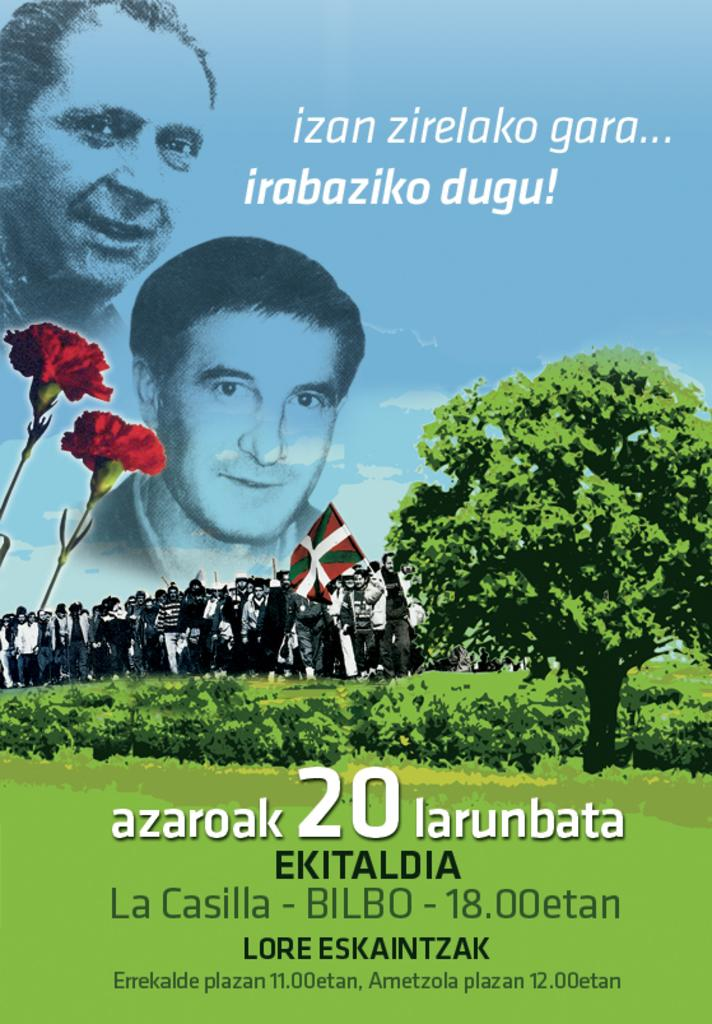Provide a one-sentence caption for the provided image. Poster that says "azaroak 20 larunbata" showing a man's face next to a tree. 